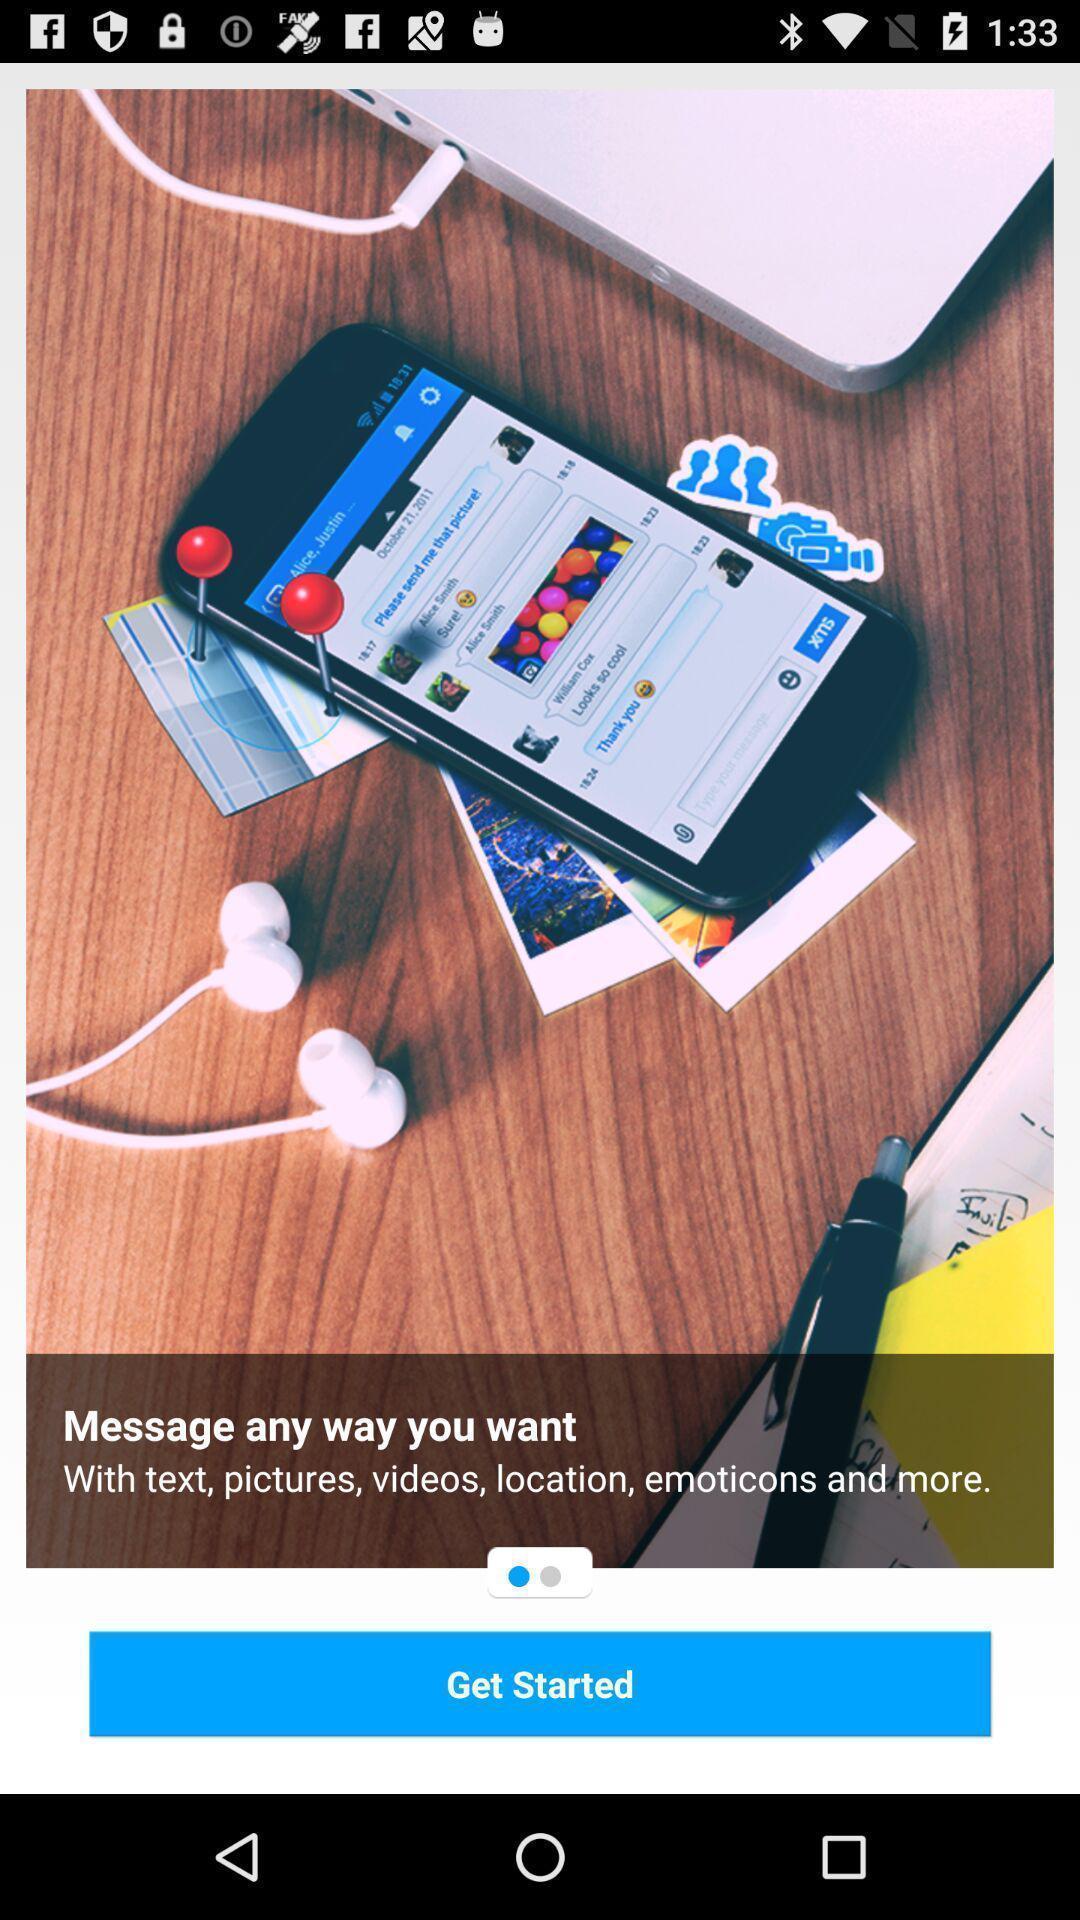Summarize the information in this screenshot. Start page. 